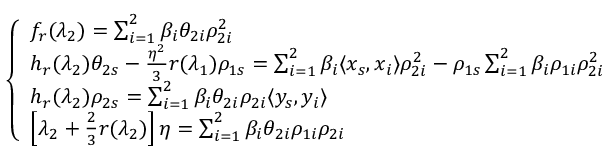<formula> <loc_0><loc_0><loc_500><loc_500>\left \{ \begin{array} { l l } { f _ { r } ( \lambda _ { 2 } ) = \sum _ { i = 1 } ^ { 2 } \beta _ { i } \theta _ { 2 i } \rho _ { 2 i } ^ { 2 } } \\ { h _ { r } ( \lambda _ { 2 } ) \theta _ { 2 s } - \frac { \eta ^ { 2 } } { 3 } r ( \lambda _ { 1 } ) \rho _ { 1 s } = \sum _ { i = 1 } ^ { 2 } \beta _ { i } \langle x _ { s } , x _ { i } \rangle \rho _ { 2 i } ^ { 2 } - \rho _ { 1 s } \sum _ { i = 1 } ^ { 2 } \beta _ { i } \rho _ { 1 i } \rho _ { 2 i } ^ { 2 } } \\ { h _ { r } ( \lambda _ { 2 } ) \rho _ { 2 s } = \sum _ { i = 1 } ^ { 2 } \beta _ { i } \theta _ { 2 i } \rho _ { 2 i } \langle y _ { s } , y _ { i } \rangle } \\ { \left [ \lambda _ { 2 } + \frac { 2 } { 3 } r ( \lambda _ { 2 } ) \right ] \eta = \sum _ { i = 1 } ^ { 2 } \beta _ { i } \theta _ { 2 i } \rho _ { 1 i } \rho _ { 2 i } } \end{array}</formula> 